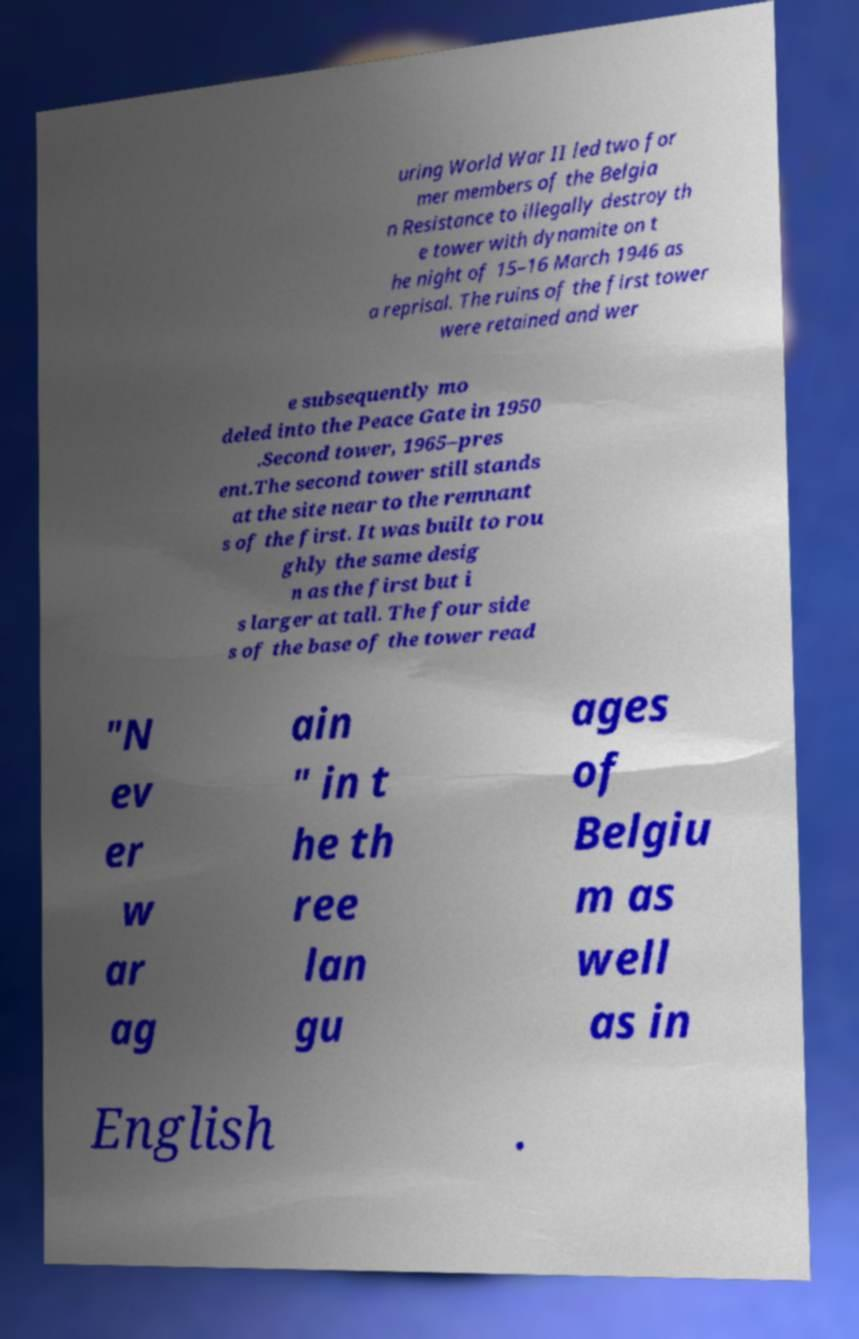There's text embedded in this image that I need extracted. Can you transcribe it verbatim? uring World War II led two for mer members of the Belgia n Resistance to illegally destroy th e tower with dynamite on t he night of 15–16 March 1946 as a reprisal. The ruins of the first tower were retained and wer e subsequently mo deled into the Peace Gate in 1950 .Second tower, 1965–pres ent.The second tower still stands at the site near to the remnant s of the first. It was built to rou ghly the same desig n as the first but i s larger at tall. The four side s of the base of the tower read "N ev er w ar ag ain " in t he th ree lan gu ages of Belgiu m as well as in English . 